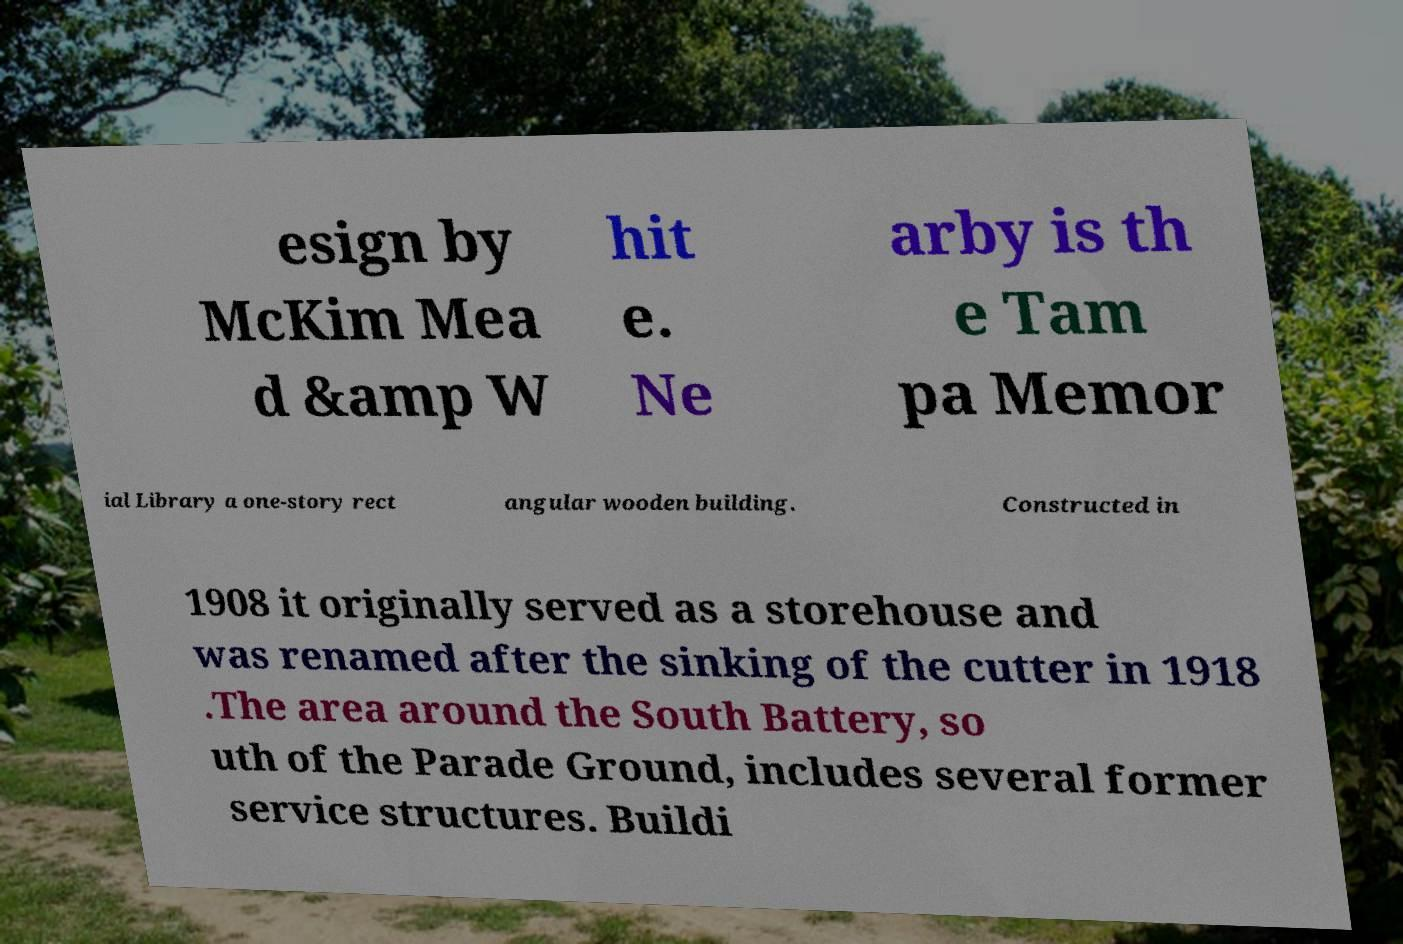For documentation purposes, I need the text within this image transcribed. Could you provide that? esign by McKim Mea d &amp W hit e. Ne arby is th e Tam pa Memor ial Library a one-story rect angular wooden building. Constructed in 1908 it originally served as a storehouse and was renamed after the sinking of the cutter in 1918 .The area around the South Battery, so uth of the Parade Ground, includes several former service structures. Buildi 